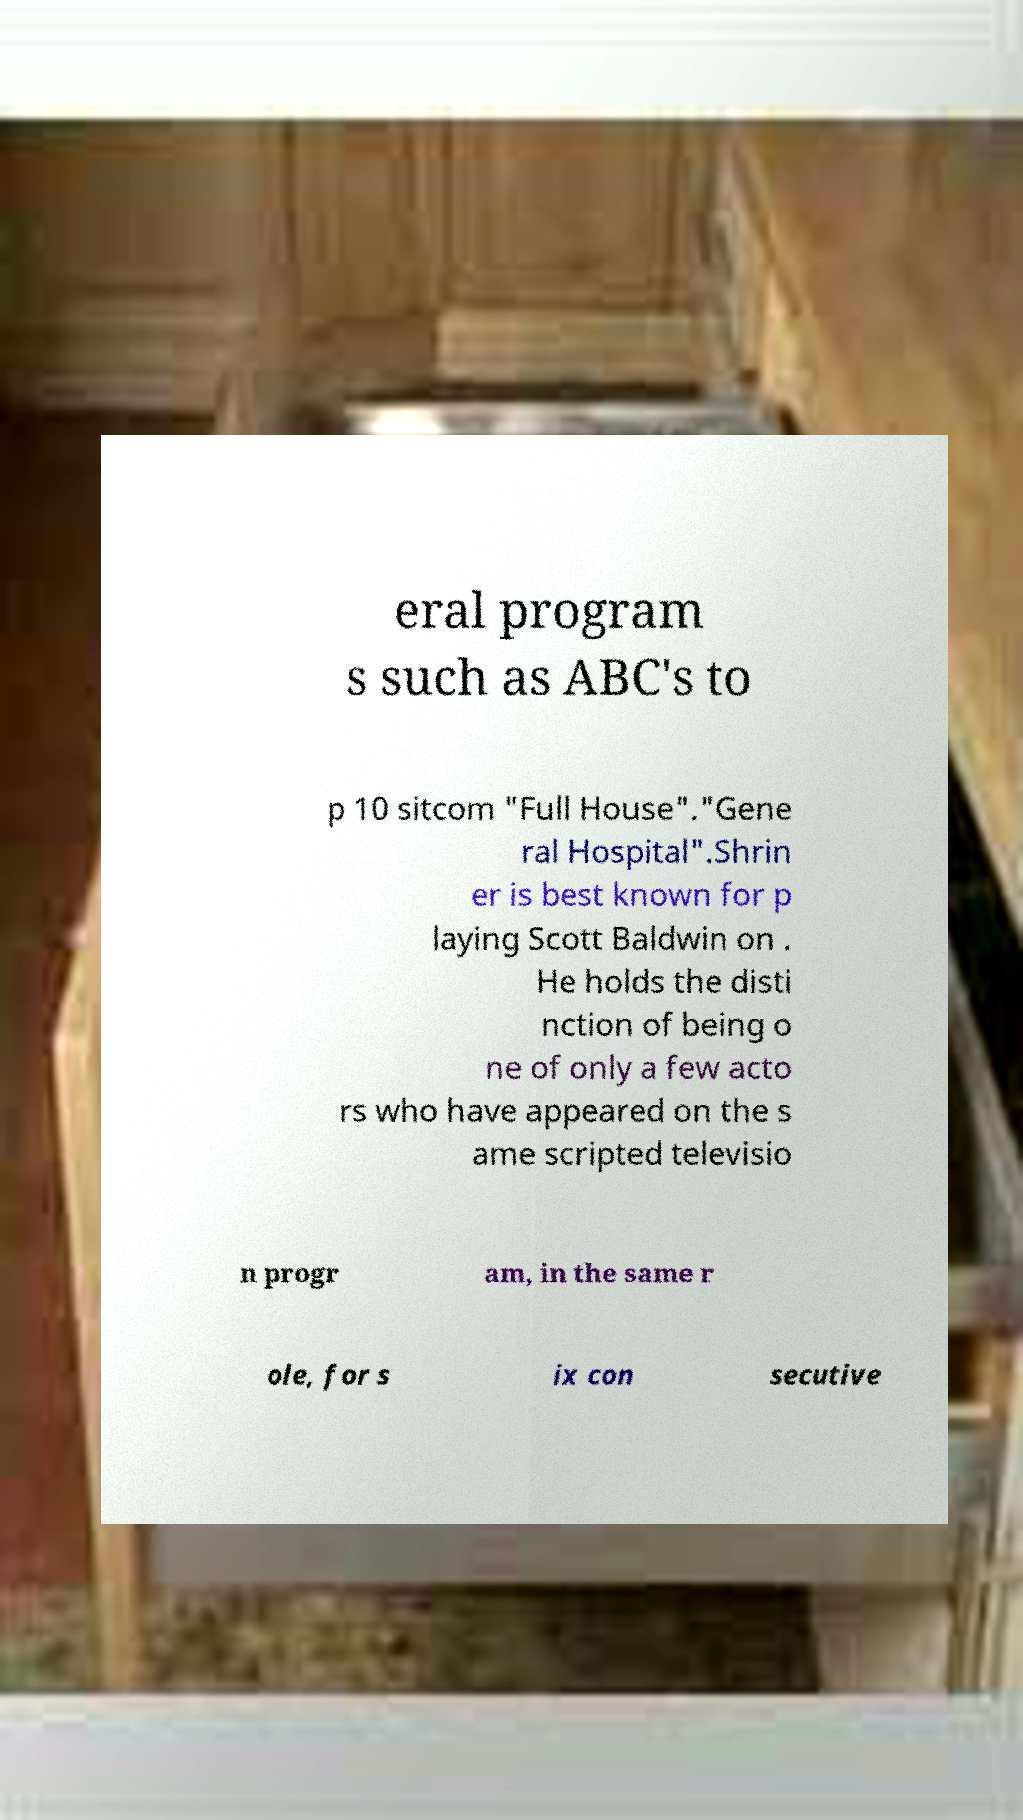Can you accurately transcribe the text from the provided image for me? eral program s such as ABC's to p 10 sitcom "Full House"."Gene ral Hospital".Shrin er is best known for p laying Scott Baldwin on . He holds the disti nction of being o ne of only a few acto rs who have appeared on the s ame scripted televisio n progr am, in the same r ole, for s ix con secutive 